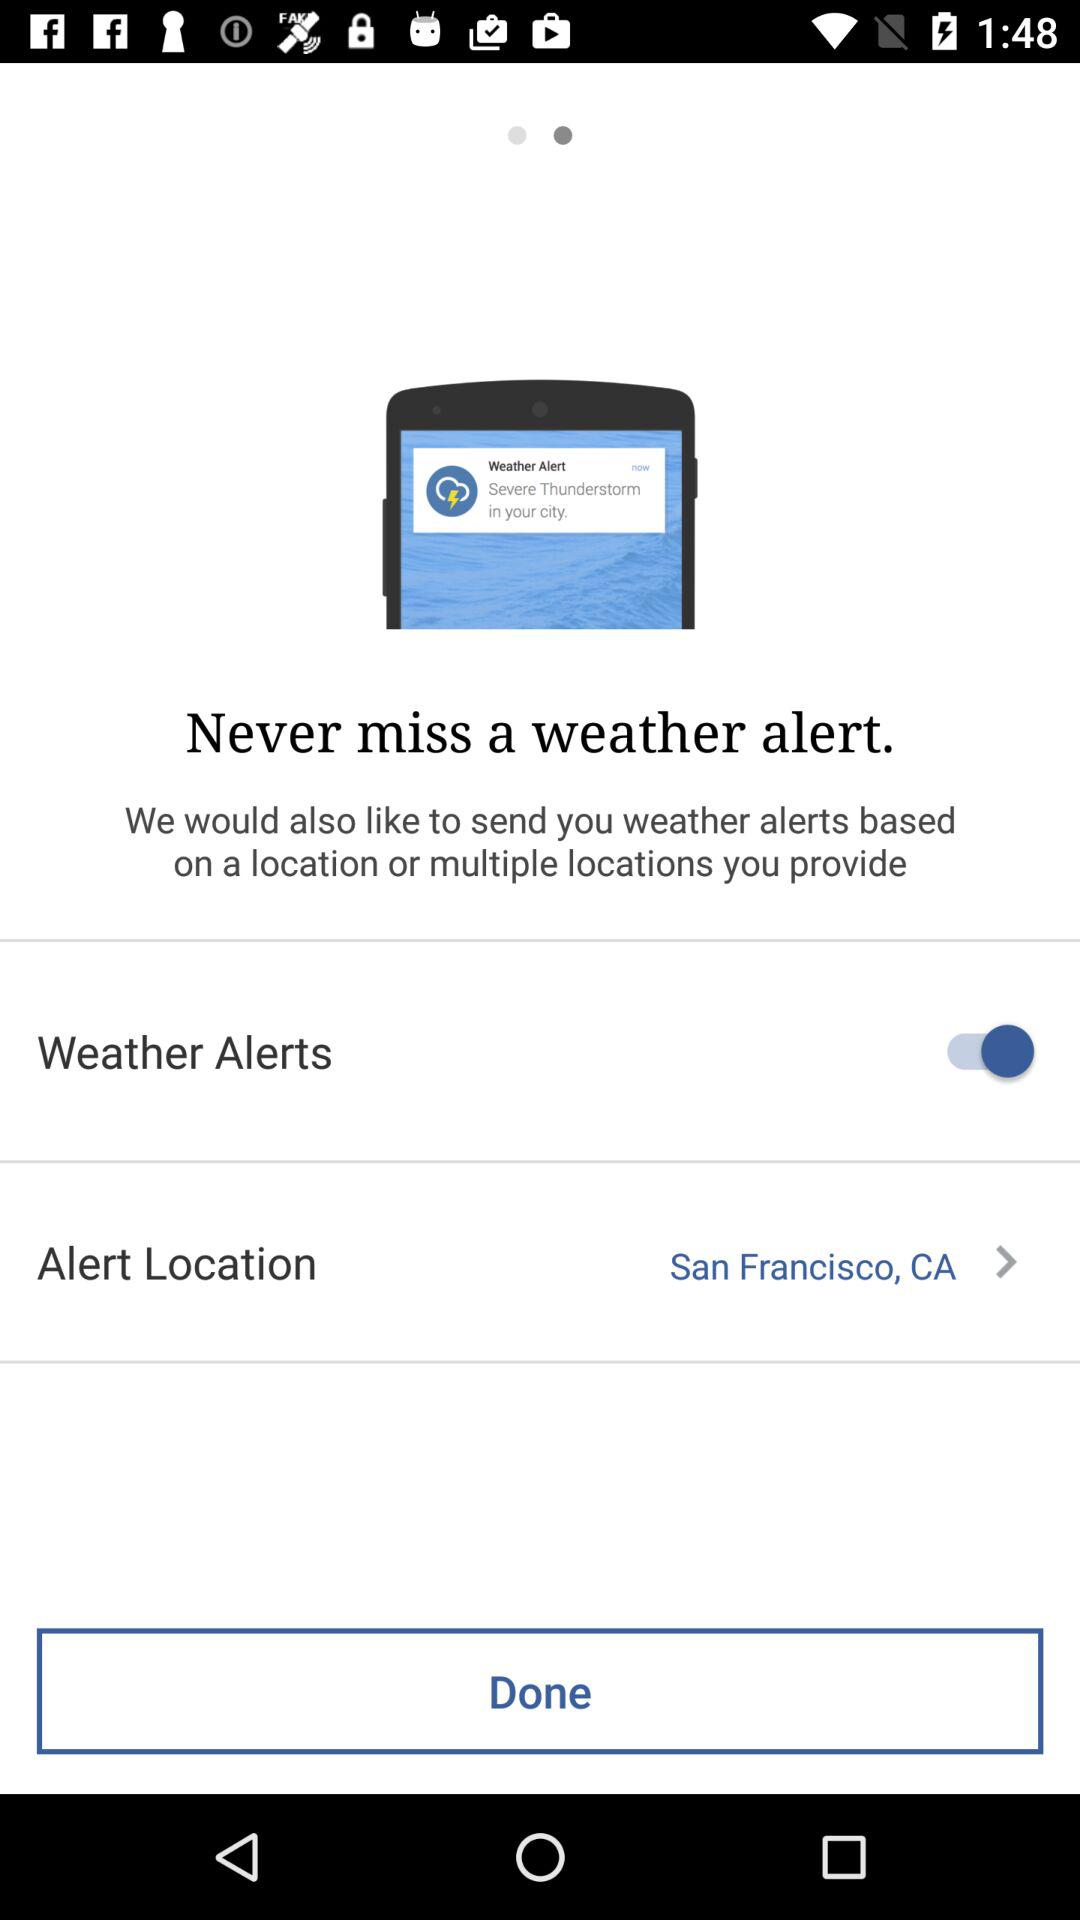What is the status of weather alerts? The status is on. 